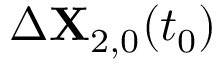Convert formula to latex. <formula><loc_0><loc_0><loc_500><loc_500>\Delta X _ { 2 , 0 } ( t _ { 0 } )</formula> 